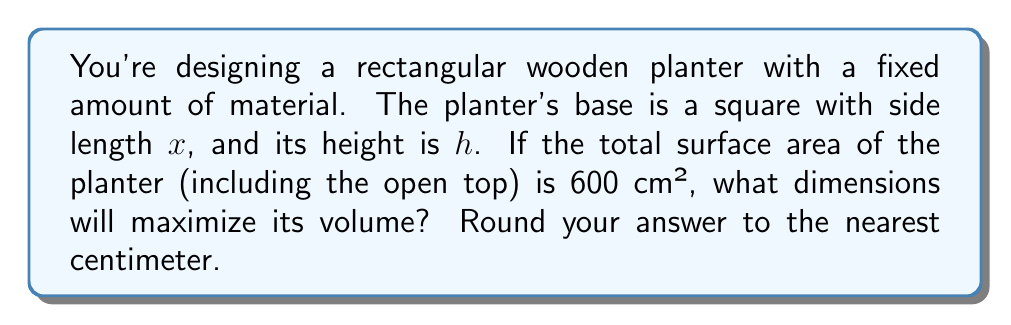Can you answer this question? Let's approach this step-by-step:

1) First, we need to express the surface area and volume in terms of $x$ and $h$:

   Surface area: $SA = x^2 + 4xh = 600$ (base + 4 sides)
   Volume: $V = x^2h$

2) From the surface area equation, we can express $h$ in terms of $x$:
   
   $x^2 + 4xh = 600$
   $4xh = 600 - x^2$
   $h = \frac{600 - x^2}{4x}$

3) Now we can express the volume solely in terms of $x$:

   $V = x^2 \cdot \frac{600 - x^2}{4x} = \frac{600x - x^3}{4}$

4) To find the maximum volume, we need to find where the derivative of $V$ with respect to $x$ is zero:

   $\frac{dV}{dx} = \frac{600 - 3x^2}{4} = 0$

5) Solving this equation:

   $600 - 3x^2 = 0$
   $3x^2 = 600$
   $x^2 = 200$
   $x = \sqrt{200} \approx 14.14$

6) Rounding to the nearest centimeter, $x = 14$ cm.

7) To find $h$, we substitute this value back into the equation from step 2:

   $h = \frac{600 - 14^2}{4(14)} = \frac{404}{56} \approx 7.21$

8) Rounding to the nearest centimeter, $h = 7$ cm.

Therefore, the dimensions that maximize the volume are approximately 14 cm × 14 cm × 7 cm (length × width × height).
Answer: 14 cm × 14 cm × 7 cm 